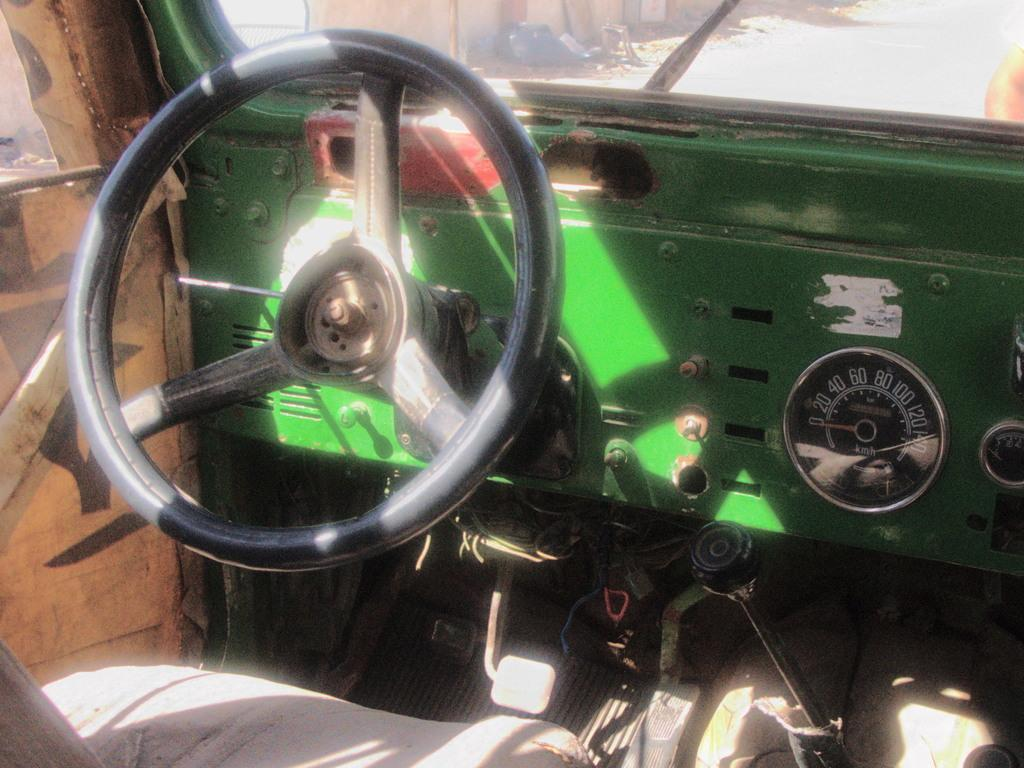What is the primary control mechanism visible in the image? There is a steering wheel in the image. What device is used to measure the speed of the vehicle in the image? There is a speedometer in the image. What is used to control the acceleration of the vehicle in the image? There is an accelerator in the image. What is used to provide a view of the rear or side of the vehicle in the image? There is a mirror in the image. What can be seen outside the vehicle in the image? There is a road visible in the image. What is the seating arrangement like in the vehicle in the image? There is a seat in the image. How can the occupants enter or exit the vehicle in the image? There is a door in the image. What is the weight of the bee flying near the vehicle in the image? There is no bee visible in the image, so it is not possible to determine its weight. 